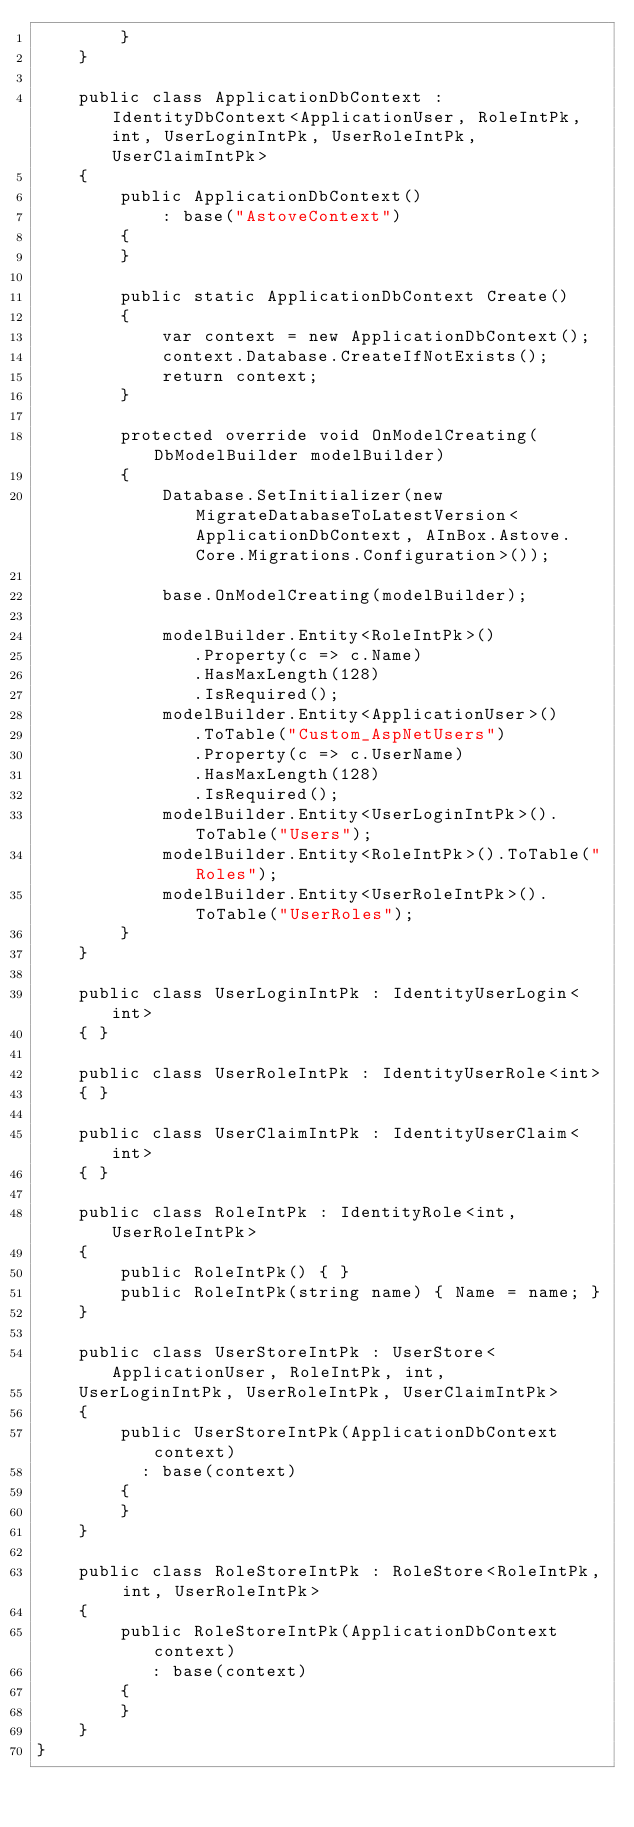Convert code to text. <code><loc_0><loc_0><loc_500><loc_500><_C#_>        }
    }

    public class ApplicationDbContext : IdentityDbContext<ApplicationUser, RoleIntPk, int, UserLoginIntPk, UserRoleIntPk, UserClaimIntPk>
    {
        public ApplicationDbContext()
            : base("AstoveContext")
        {
        }

        public static ApplicationDbContext Create()
        {
            var context = new ApplicationDbContext();
            context.Database.CreateIfNotExists();
            return context;
        }

        protected override void OnModelCreating(DbModelBuilder modelBuilder)
        {
            Database.SetInitializer(new MigrateDatabaseToLatestVersion<ApplicationDbContext, AInBox.Astove.Core.Migrations.Configuration>());

            base.OnModelCreating(modelBuilder);

            modelBuilder.Entity<RoleIntPk>()
               .Property(c => c.Name)
               .HasMaxLength(128)
               .IsRequired();
            modelBuilder.Entity<ApplicationUser>()
               .ToTable("Custom_AspNetUsers")
               .Property(c => c.UserName)
               .HasMaxLength(128)
               .IsRequired();
            modelBuilder.Entity<UserLoginIntPk>().ToTable("Users");
            modelBuilder.Entity<RoleIntPk>().ToTable("Roles");
            modelBuilder.Entity<UserRoleIntPk>().ToTable("UserRoles");
        }
    }

    public class UserLoginIntPk : IdentityUserLogin<int>
    { }

    public class UserRoleIntPk : IdentityUserRole<int>
    { }

    public class UserClaimIntPk : IdentityUserClaim<int>
    { }

    public class RoleIntPk : IdentityRole<int, UserRoleIntPk>
    {
        public RoleIntPk() { }
        public RoleIntPk(string name) { Name = name; }
    }

    public class UserStoreIntPk : UserStore<ApplicationUser, RoleIntPk, int,
    UserLoginIntPk, UserRoleIntPk, UserClaimIntPk>
    {
        public UserStoreIntPk(ApplicationDbContext context)
          : base(context)
        {
        }
    }

    public class RoleStoreIntPk : RoleStore<RoleIntPk, int, UserRoleIntPk>
    {
        public RoleStoreIntPk(ApplicationDbContext context)
           : base(context)
        {
        }
    }
}</code> 